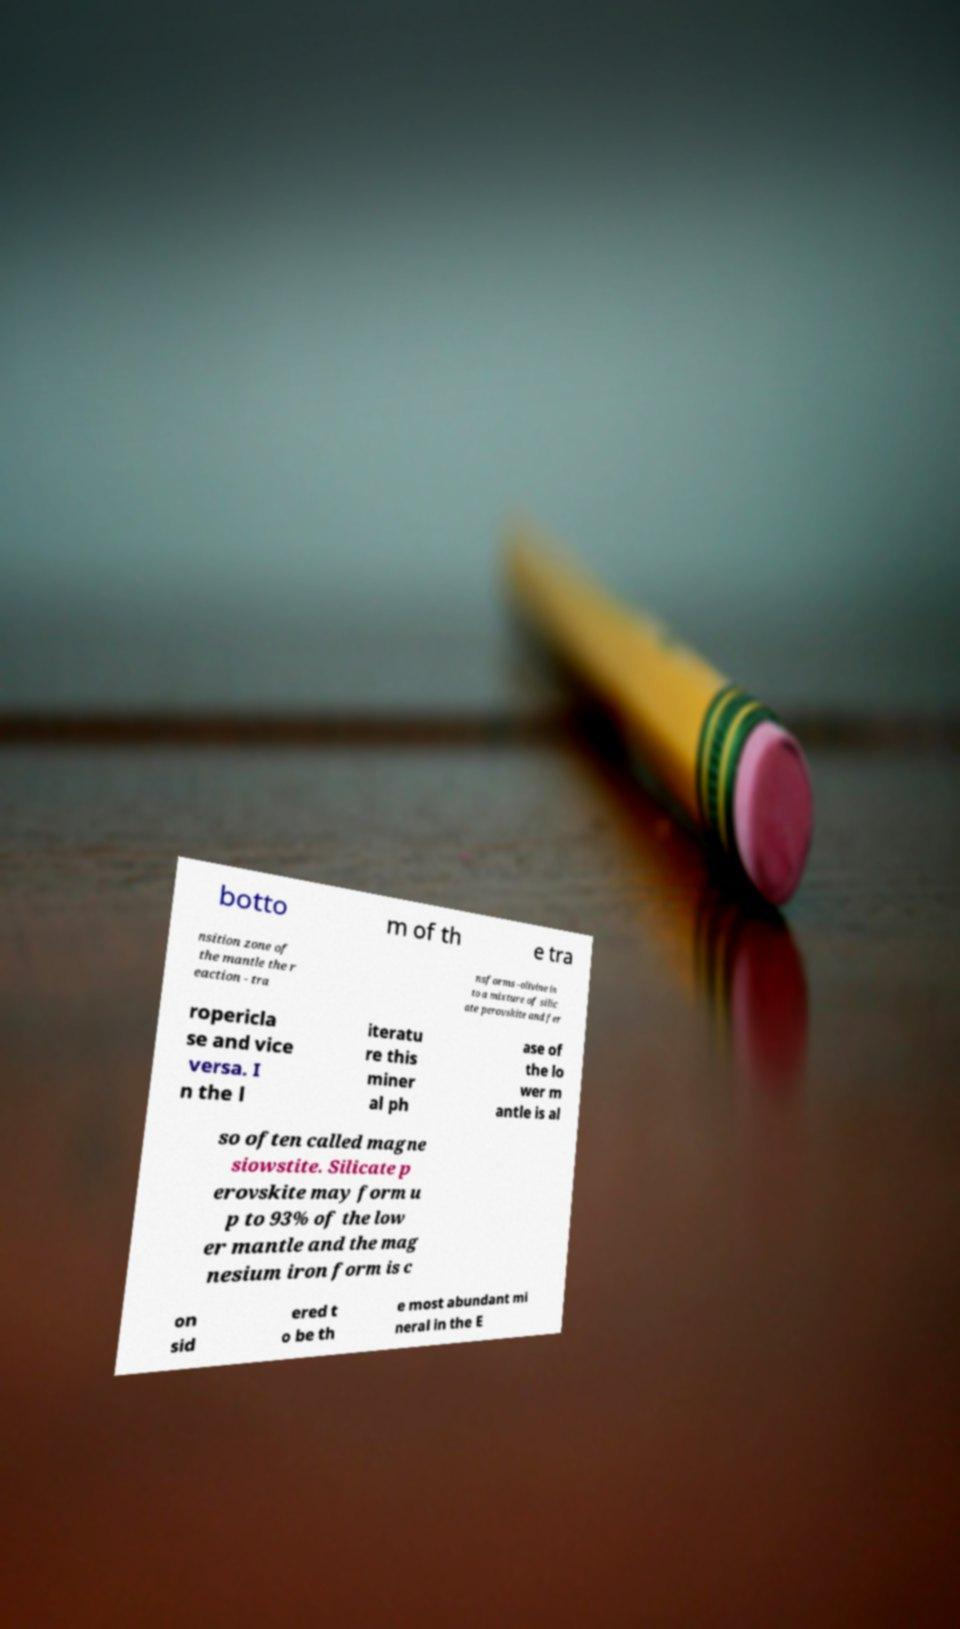Please identify and transcribe the text found in this image. botto m of th e tra nsition zone of the mantle the r eaction - tra nsforms -olivine in to a mixture of silic ate perovskite and fer ropericla se and vice versa. I n the l iteratu re this miner al ph ase of the lo wer m antle is al so often called magne siowstite. Silicate p erovskite may form u p to 93% of the low er mantle and the mag nesium iron form is c on sid ered t o be th e most abundant mi neral in the E 